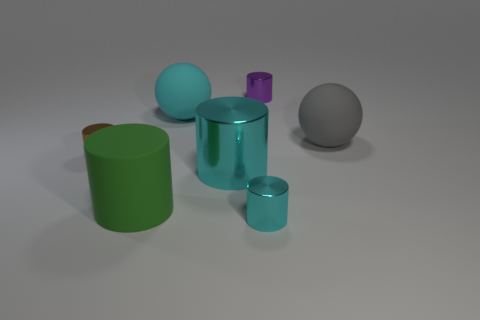Add 3 cyan rubber cylinders. How many objects exist? 10 Subtract all cyan spheres. How many spheres are left? 1 Subtract all large green matte cylinders. How many cylinders are left? 4 Subtract 0 blue cubes. How many objects are left? 7 Subtract all spheres. How many objects are left? 5 Subtract 2 spheres. How many spheres are left? 0 Subtract all gray balls. Subtract all blue cubes. How many balls are left? 1 Subtract all purple spheres. How many blue cylinders are left? 0 Subtract all gray matte balls. Subtract all tiny cyan cylinders. How many objects are left? 5 Add 4 small purple cylinders. How many small purple cylinders are left? 5 